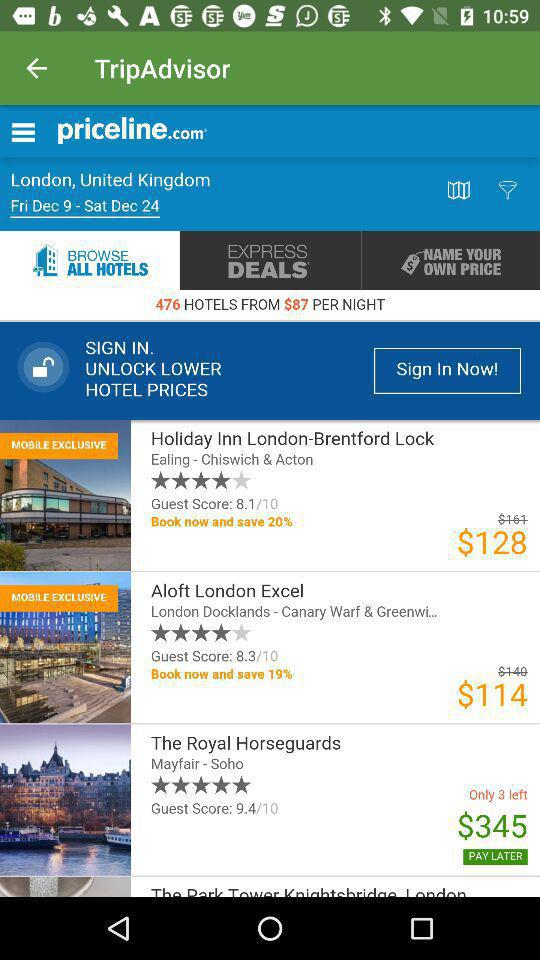How many hotels in total are there? There are 476 hotels. 